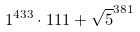Convert formula to latex. <formula><loc_0><loc_0><loc_500><loc_500>1 ^ { 4 3 3 } \cdot 1 1 1 + \sqrt { 5 } ^ { 3 8 1 }</formula> 